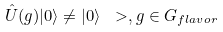Convert formula to latex. <formula><loc_0><loc_0><loc_500><loc_500>\hat { U } ( g ) | 0 \rangle \neq | 0 \rangle \ > , g \in G _ { f l a v o r }</formula> 